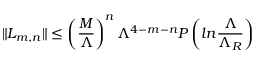Convert formula to latex. <formula><loc_0><loc_0><loc_500><loc_500>\| L _ { m , n } \| \leq \left ( { \frac { M } { \Lambda } } \right ) ^ { n } \Lambda ^ { 4 - m - n } P \left ( \ln { \frac { \Lambda } { \Lambda _ { R } } } \right )</formula> 